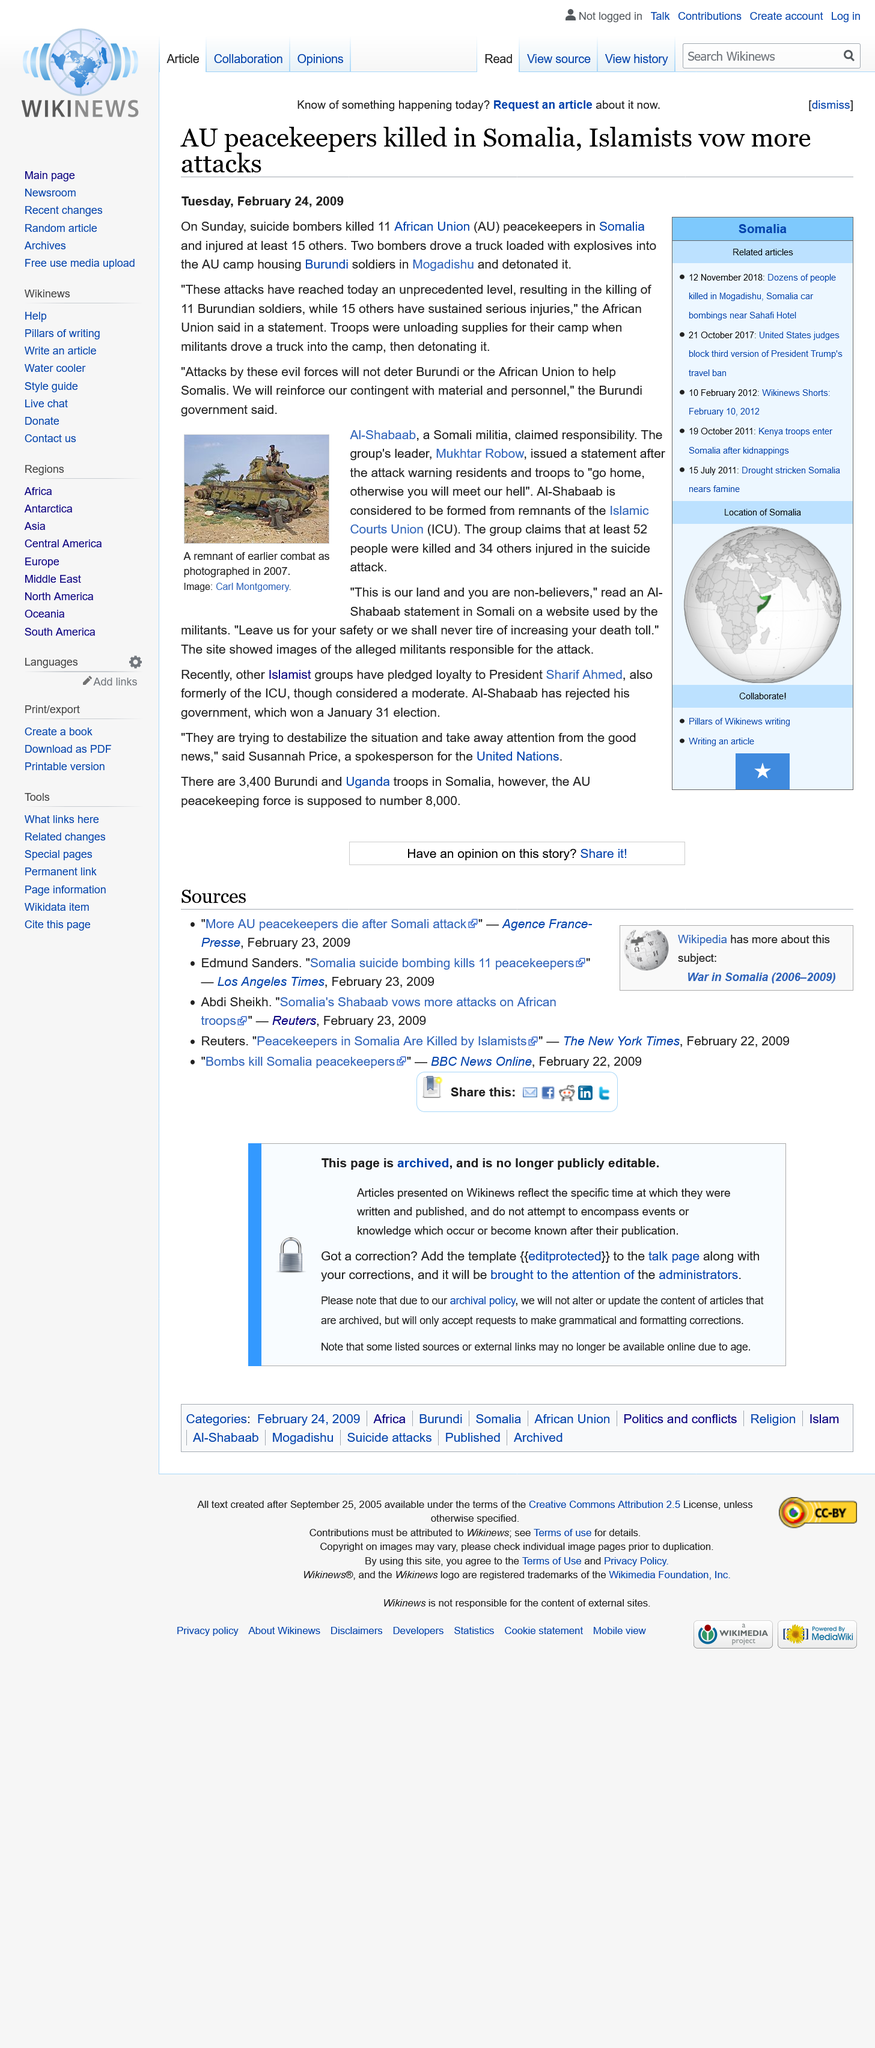List a handful of essential elements in this visual. On Sunday February 22, 2009, suicide bombers killed 11 African Union peacekeepers in a deadly attack that occurred. In total, 11 African Union peacekeepers lost their lives during the conflict. The attack occurred at the African Union camp in Mogadishu, Somalia. 